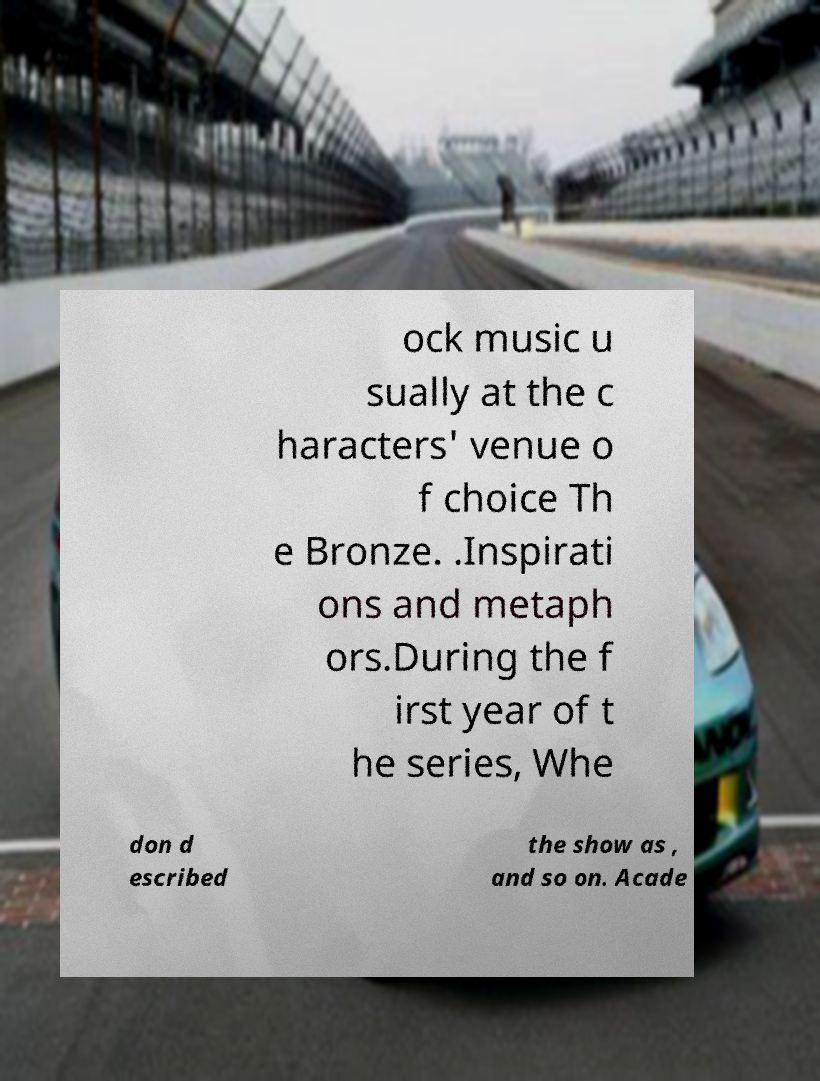There's text embedded in this image that I need extracted. Can you transcribe it verbatim? ock music u sually at the c haracters' venue o f choice Th e Bronze. .Inspirati ons and metaph ors.During the f irst year of t he series, Whe don d escribed the show as , and so on. Acade 